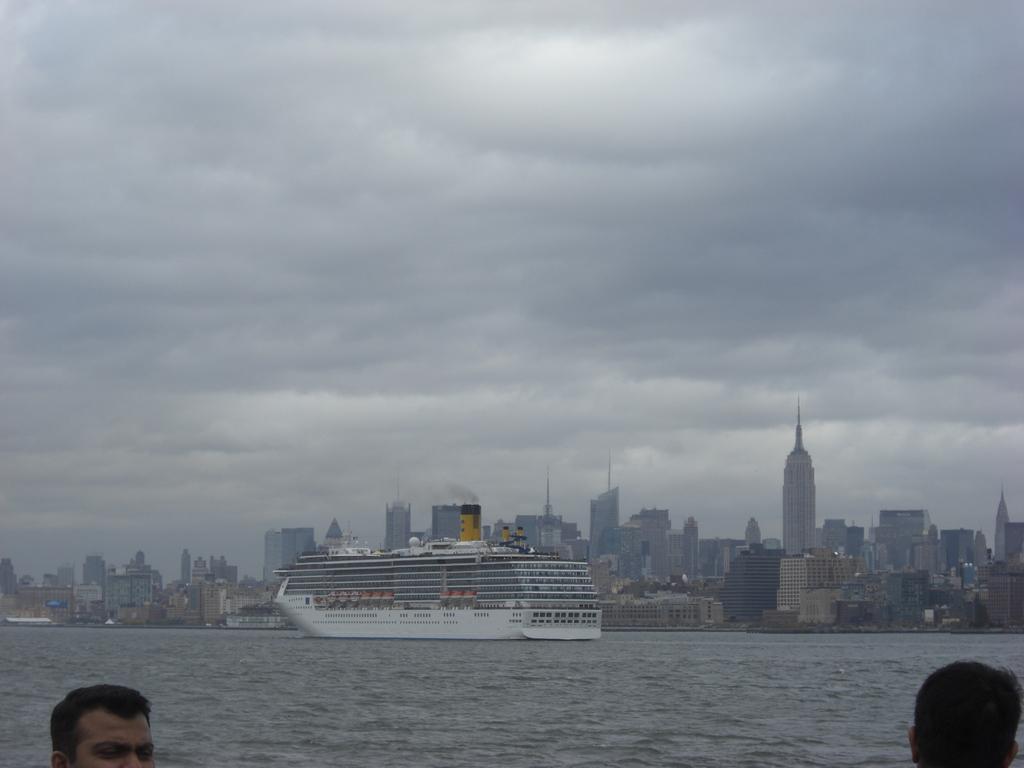Describe this image in one or two sentences. In the center of the image we can see a ship on the water. At the bottom there are people. In the background there are buildings and sky. 